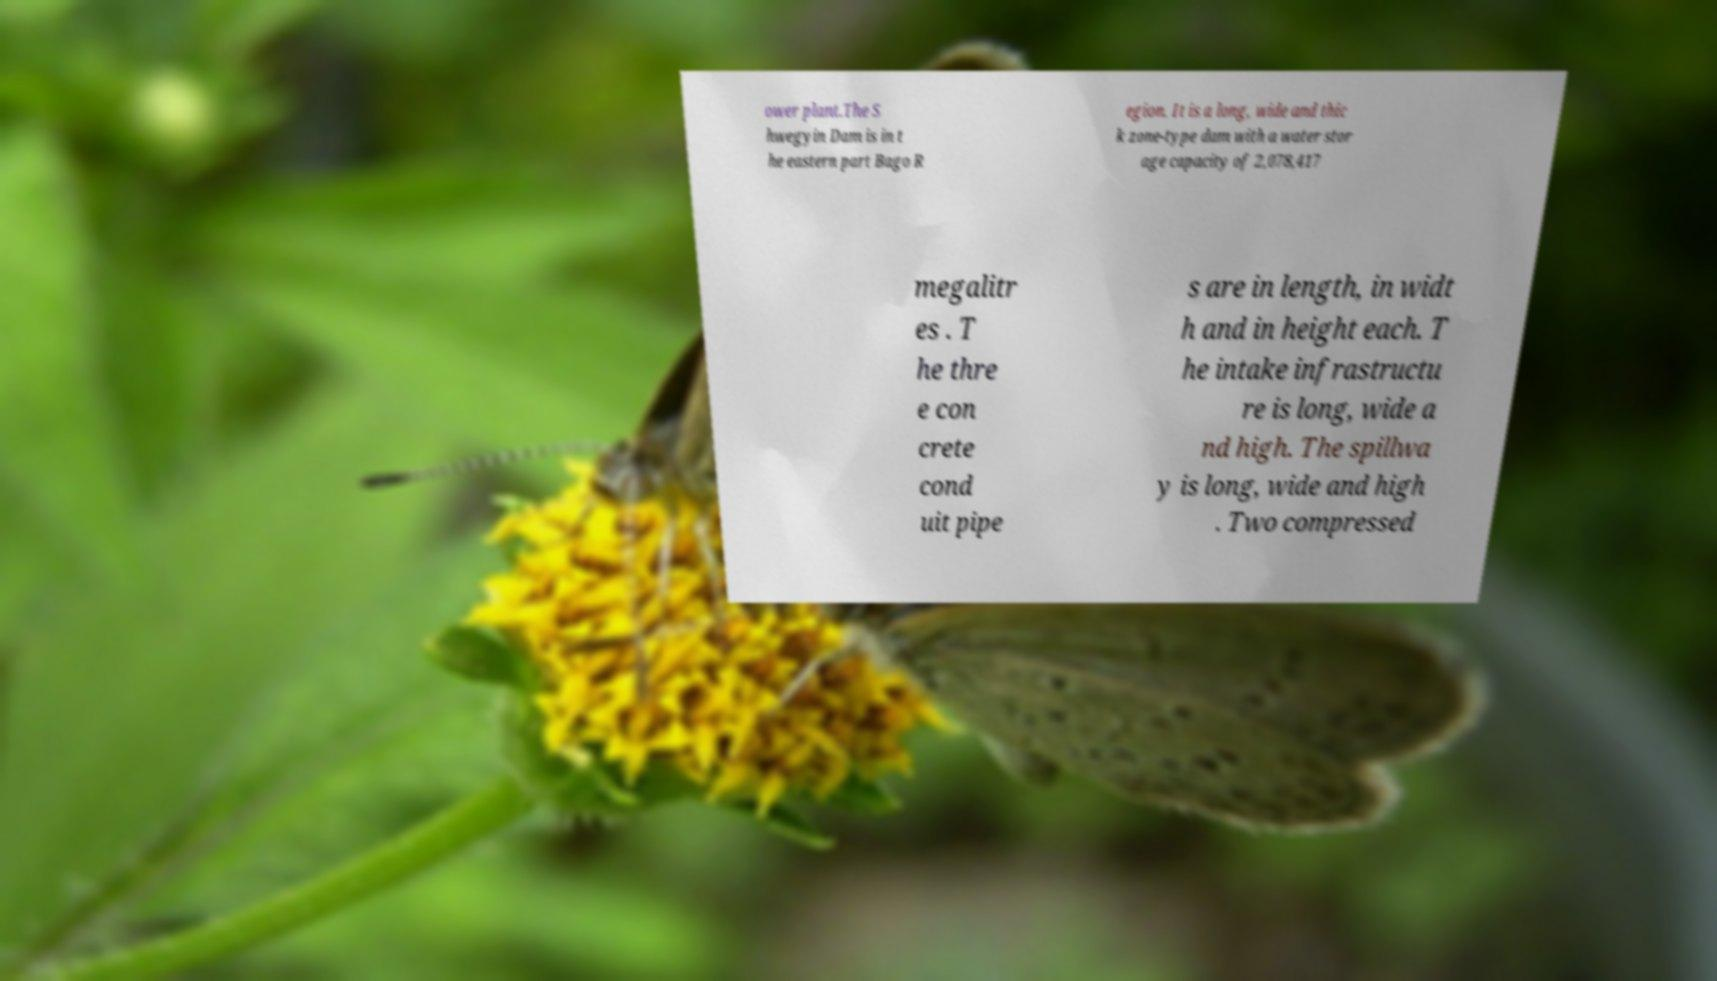Please identify and transcribe the text found in this image. ower plant.The S hwegyin Dam is in t he eastern part Bago R egion. It is a long, wide and thic k zone-type dam with a water stor age capacity of 2,078,417 megalitr es . T he thre e con crete cond uit pipe s are in length, in widt h and in height each. T he intake infrastructu re is long, wide a nd high. The spillwa y is long, wide and high . Two compressed 